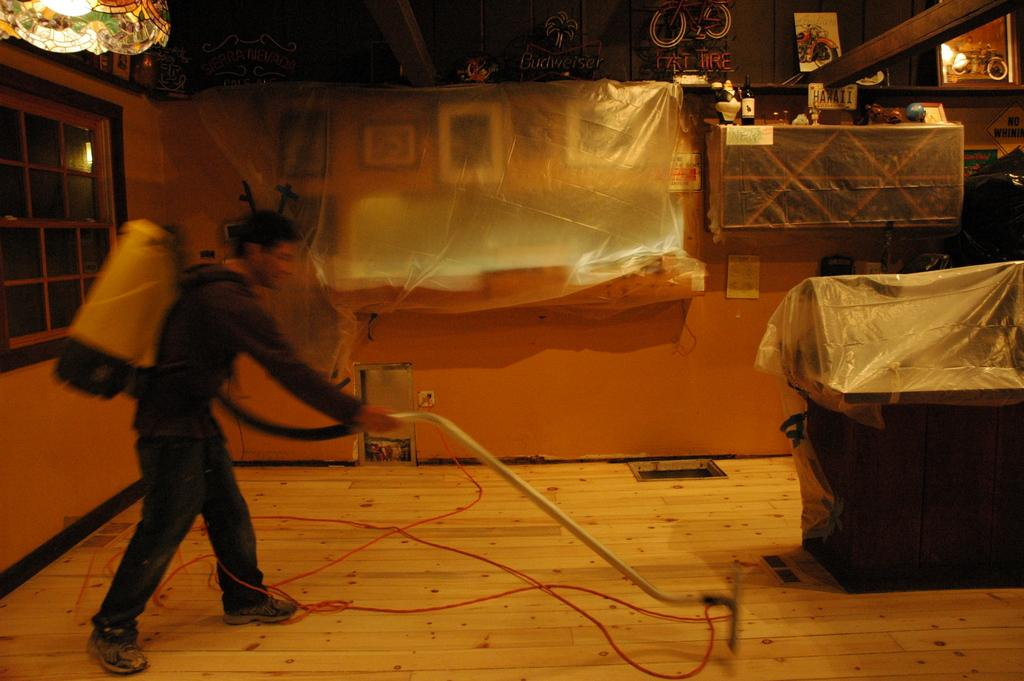What is the human in the image doing? The human is using a vacuum cleaner. What might the human be cleaning in the image? It is not clear what the human is cleaning, but the vacuum cleaner suggests they are cleaning a surface or area. Can you describe any additional details about the items in the image? Yes, there are covers on some items in the image. What type of writing can be seen on the canvas in the image? There is no canvas or writing present in the image. 